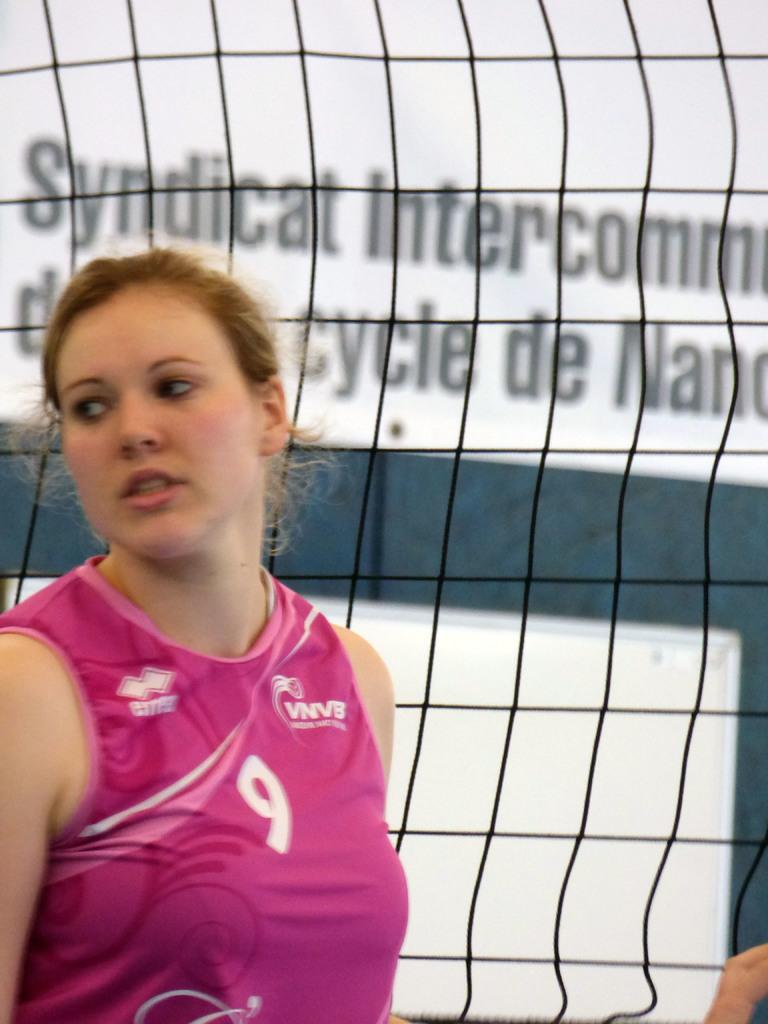<image>
Summarize the visual content of the image. A woman in a number 9 jersey stands in front of a net. 